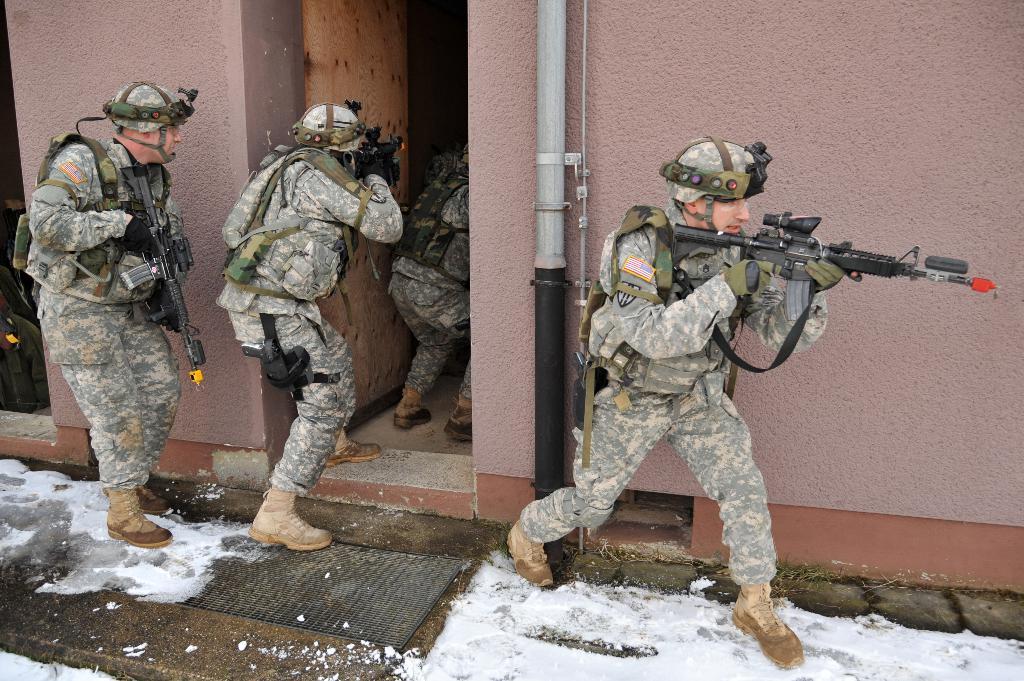Can you describe this image briefly? In the image there are few men with army uniforms, caps on their heads and holding guns in their hands. Behind them there is a wall with pipe 